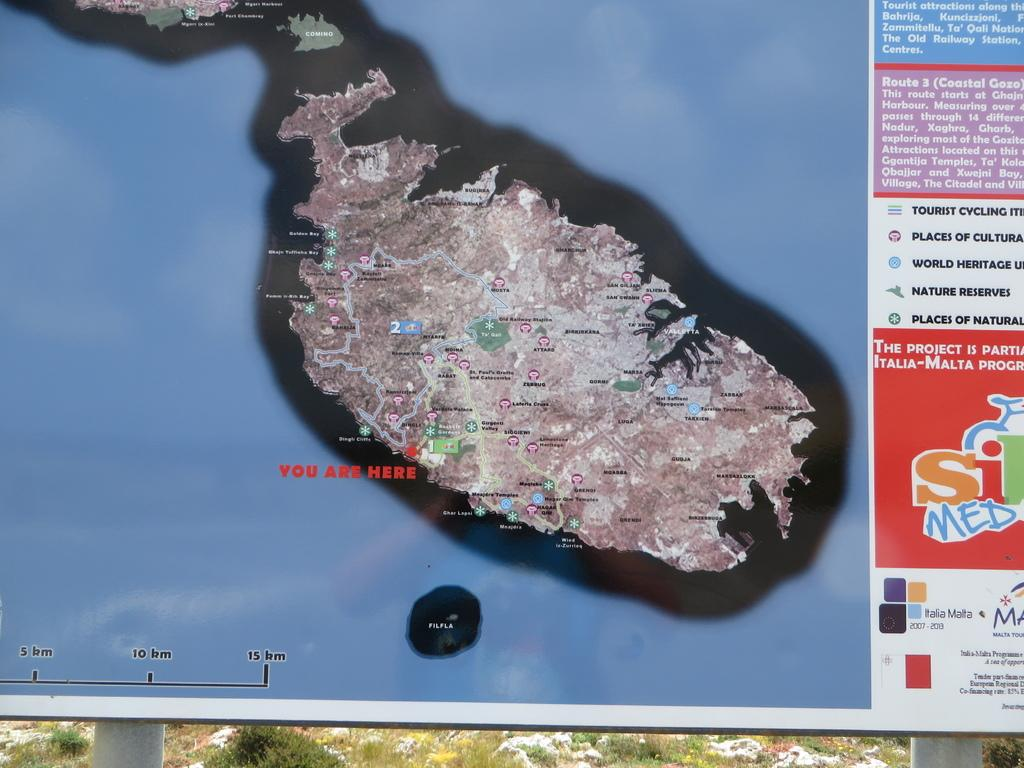What is the main subject of the image? There is a map poster in the image. Can you describe the map poster in more detail? Unfortunately, the provided facts do not give any additional details about the map poster. How many flies can be seen on the map poster in the image? There is no mention of flies in the provided facts, so it cannot be determined if any are present on the map poster. 